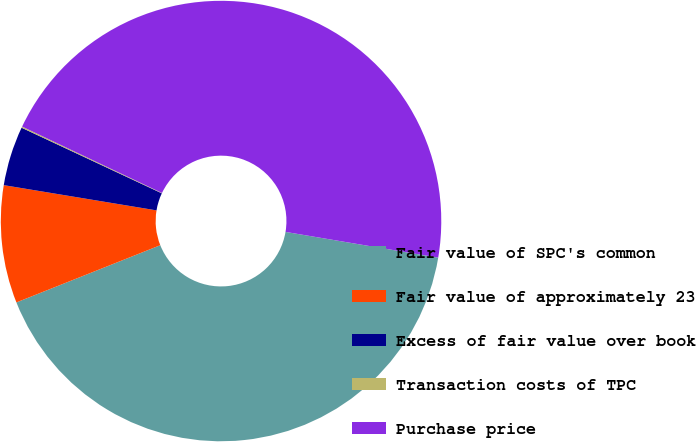Convert chart. <chart><loc_0><loc_0><loc_500><loc_500><pie_chart><fcel>Fair value of SPC's common<fcel>Fair value of approximately 23<fcel>Excess of fair value over book<fcel>Transaction costs of TPC<fcel>Purchase price<nl><fcel>41.32%<fcel>8.63%<fcel>4.36%<fcel>0.09%<fcel>45.6%<nl></chart> 